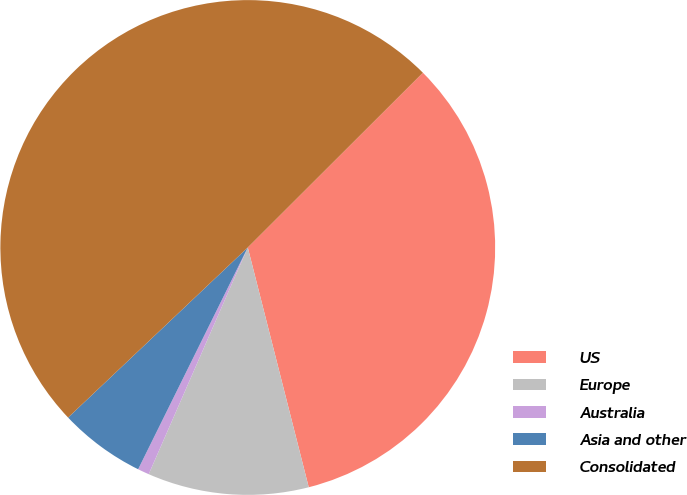<chart> <loc_0><loc_0><loc_500><loc_500><pie_chart><fcel>US<fcel>Europe<fcel>Australia<fcel>Asia and other<fcel>Consolidated<nl><fcel>33.52%<fcel>10.52%<fcel>0.75%<fcel>5.63%<fcel>49.58%<nl></chart> 